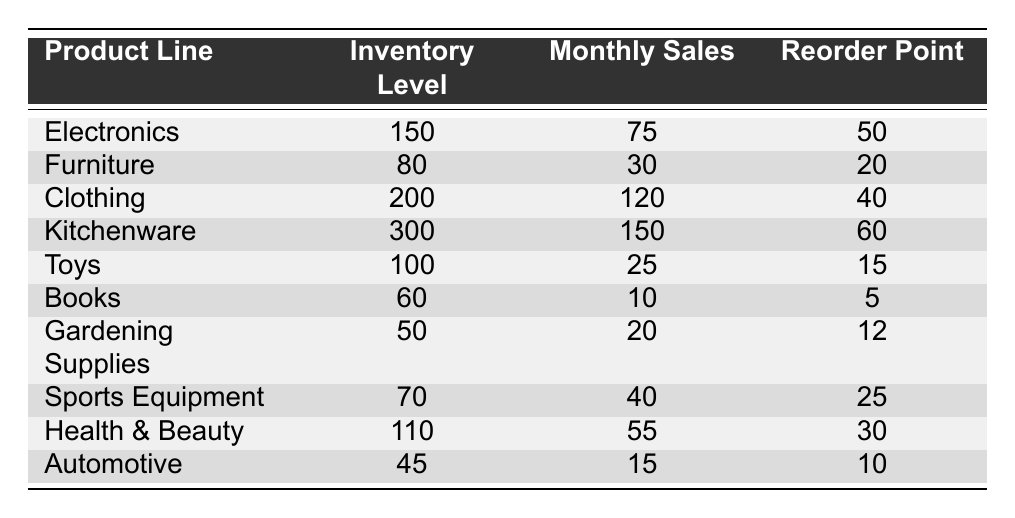What is the inventory level for Kitchenware? The inventory level for Kitchenware is directly recorded in the table as 300.
Answer: 300 Which product line has the highest monthly sales? By comparing the monthly sales values, Clothing has the highest sales at 120.
Answer: Clothing Is the inventory level for Books above its reorder point? The reorder point for Books is 5, and its inventory level is 60, which is above the reorder point.
Answer: Yes What is the total inventory level for all product lines? Summing all inventory levels: 150 + 80 + 200 + 300 + 100 + 60 + 50 + 70 + 110 + 45 = 1165.
Answer: 1165 Which product line has inventory levels below its reorder point? Comparing each product line's inventory level with its reorder point, only Automotive has an inventory level of 45, which is below its reorder point of 10.
Answer: Automotive What is the average monthly sales across all product lines? To find the average, sum the monthly sales: 75 + 30 + 120 + 150 + 25 + 10 + 20 + 40 + 55 + 15 = 520, and then divide by the number of product lines (10): 520 / 10 = 52.
Answer: 52 How many product lines have inventory levels greater than 100? The product lines with inventory levels over 100 are Electronics, Clothing, and Kitchenware, making a total of 3 lines.
Answer: 3 What is the difference in inventory levels between Clothing and Toys? The inventory level for Clothing is 200, and for Toys is 100. The difference is 200 - 100 = 100.
Answer: 100 What percentage of the total monthly sales does Kitchenware represent? Monthly sales for Kitchenware is 150, total sales = 520, hence Kitchenware's percentage is (150 / 520) * 100 = 28.85%.
Answer: 28.85% Is the monthly sales performance for Gardening Supplies more than the average monthly sales? Gardening Supplies has monthly sales of 20, while the average is 52. Since 20 is less than 52, it is not more.
Answer: No 